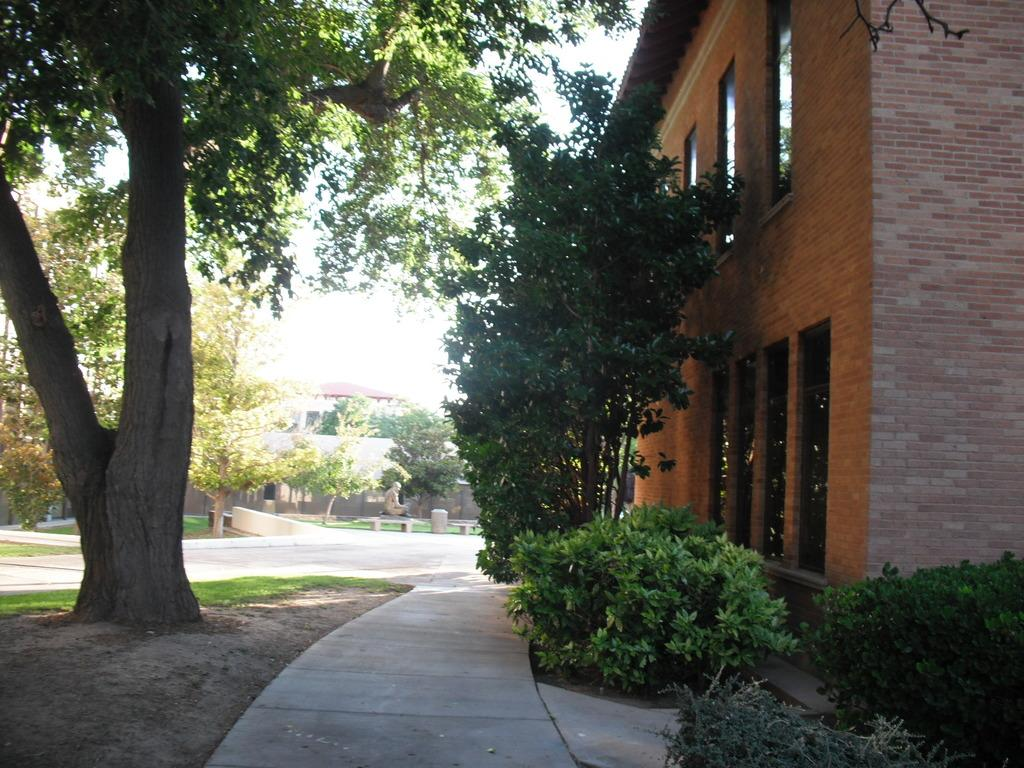What structure is located on the right side of the image? There is a house on the right side of the image. Can you describe any other buildings or structures in the image? There is another house in the background of the image. What type of natural environment is visible in the image? There is greenery visible in the image. How does the love between the two houses manifest in the image? There is no indication of love between the houses in the image; it is a simple depiction of two houses and greenery. 